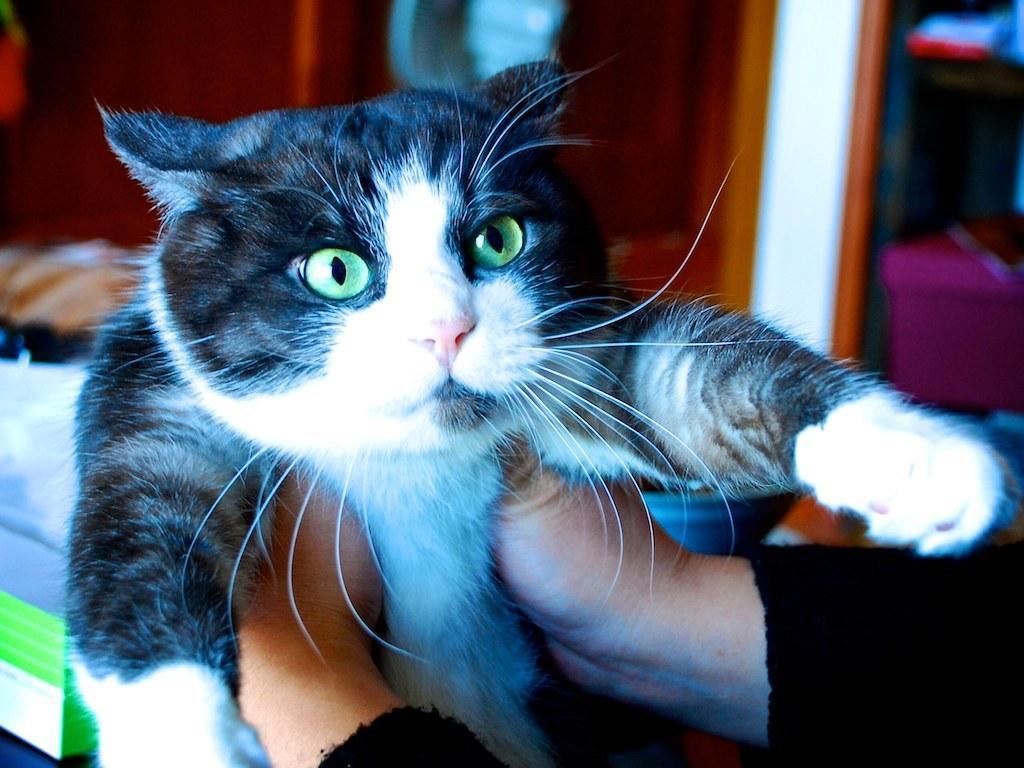Please provide a concise description of this image. In this image in the foreground there is one person who is holding a cat, and in the background there are some other objects. 